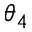<formula> <loc_0><loc_0><loc_500><loc_500>\theta _ { 4 }</formula> 